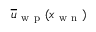<formula> <loc_0><loc_0><loc_500><loc_500>\overline { u } _ { w p } ( x _ { w n } )</formula> 